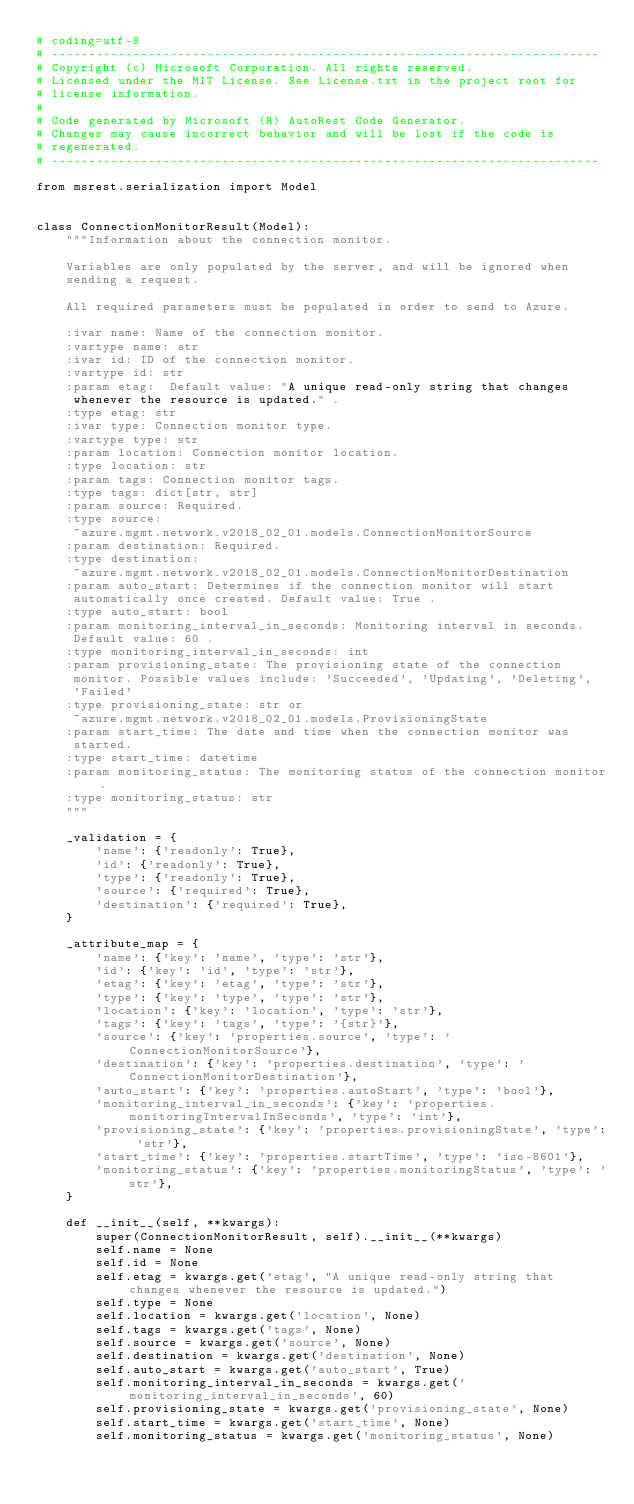<code> <loc_0><loc_0><loc_500><loc_500><_Python_># coding=utf-8
# --------------------------------------------------------------------------
# Copyright (c) Microsoft Corporation. All rights reserved.
# Licensed under the MIT License. See License.txt in the project root for
# license information.
#
# Code generated by Microsoft (R) AutoRest Code Generator.
# Changes may cause incorrect behavior and will be lost if the code is
# regenerated.
# --------------------------------------------------------------------------

from msrest.serialization import Model


class ConnectionMonitorResult(Model):
    """Information about the connection monitor.

    Variables are only populated by the server, and will be ignored when
    sending a request.

    All required parameters must be populated in order to send to Azure.

    :ivar name: Name of the connection monitor.
    :vartype name: str
    :ivar id: ID of the connection monitor.
    :vartype id: str
    :param etag:  Default value: "A unique read-only string that changes
     whenever the resource is updated." .
    :type etag: str
    :ivar type: Connection monitor type.
    :vartype type: str
    :param location: Connection monitor location.
    :type location: str
    :param tags: Connection monitor tags.
    :type tags: dict[str, str]
    :param source: Required.
    :type source:
     ~azure.mgmt.network.v2018_02_01.models.ConnectionMonitorSource
    :param destination: Required.
    :type destination:
     ~azure.mgmt.network.v2018_02_01.models.ConnectionMonitorDestination
    :param auto_start: Determines if the connection monitor will start
     automatically once created. Default value: True .
    :type auto_start: bool
    :param monitoring_interval_in_seconds: Monitoring interval in seconds.
     Default value: 60 .
    :type monitoring_interval_in_seconds: int
    :param provisioning_state: The provisioning state of the connection
     monitor. Possible values include: 'Succeeded', 'Updating', 'Deleting',
     'Failed'
    :type provisioning_state: str or
     ~azure.mgmt.network.v2018_02_01.models.ProvisioningState
    :param start_time: The date and time when the connection monitor was
     started.
    :type start_time: datetime
    :param monitoring_status: The monitoring status of the connection monitor.
    :type monitoring_status: str
    """

    _validation = {
        'name': {'readonly': True},
        'id': {'readonly': True},
        'type': {'readonly': True},
        'source': {'required': True},
        'destination': {'required': True},
    }

    _attribute_map = {
        'name': {'key': 'name', 'type': 'str'},
        'id': {'key': 'id', 'type': 'str'},
        'etag': {'key': 'etag', 'type': 'str'},
        'type': {'key': 'type', 'type': 'str'},
        'location': {'key': 'location', 'type': 'str'},
        'tags': {'key': 'tags', 'type': '{str}'},
        'source': {'key': 'properties.source', 'type': 'ConnectionMonitorSource'},
        'destination': {'key': 'properties.destination', 'type': 'ConnectionMonitorDestination'},
        'auto_start': {'key': 'properties.autoStart', 'type': 'bool'},
        'monitoring_interval_in_seconds': {'key': 'properties.monitoringIntervalInSeconds', 'type': 'int'},
        'provisioning_state': {'key': 'properties.provisioningState', 'type': 'str'},
        'start_time': {'key': 'properties.startTime', 'type': 'iso-8601'},
        'monitoring_status': {'key': 'properties.monitoringStatus', 'type': 'str'},
    }

    def __init__(self, **kwargs):
        super(ConnectionMonitorResult, self).__init__(**kwargs)
        self.name = None
        self.id = None
        self.etag = kwargs.get('etag', "A unique read-only string that changes whenever the resource is updated.")
        self.type = None
        self.location = kwargs.get('location', None)
        self.tags = kwargs.get('tags', None)
        self.source = kwargs.get('source', None)
        self.destination = kwargs.get('destination', None)
        self.auto_start = kwargs.get('auto_start', True)
        self.monitoring_interval_in_seconds = kwargs.get('monitoring_interval_in_seconds', 60)
        self.provisioning_state = kwargs.get('provisioning_state', None)
        self.start_time = kwargs.get('start_time', None)
        self.monitoring_status = kwargs.get('monitoring_status', None)
</code> 